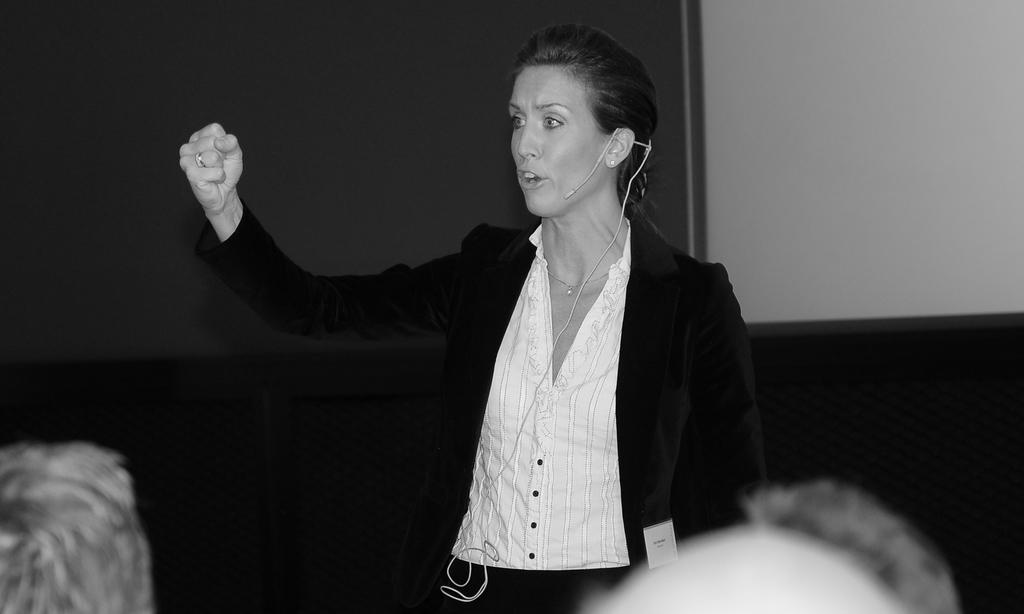What is the color scheme of the image? The image is black and white. Can you describe the person in the image? There is a person in the image, and they are wearing a mic. What is the person doing in the image? The person is speaking. What type of brass instrument is the person playing in the image? There is no brass instrument present in the image; the person is wearing a mic and speaking. 